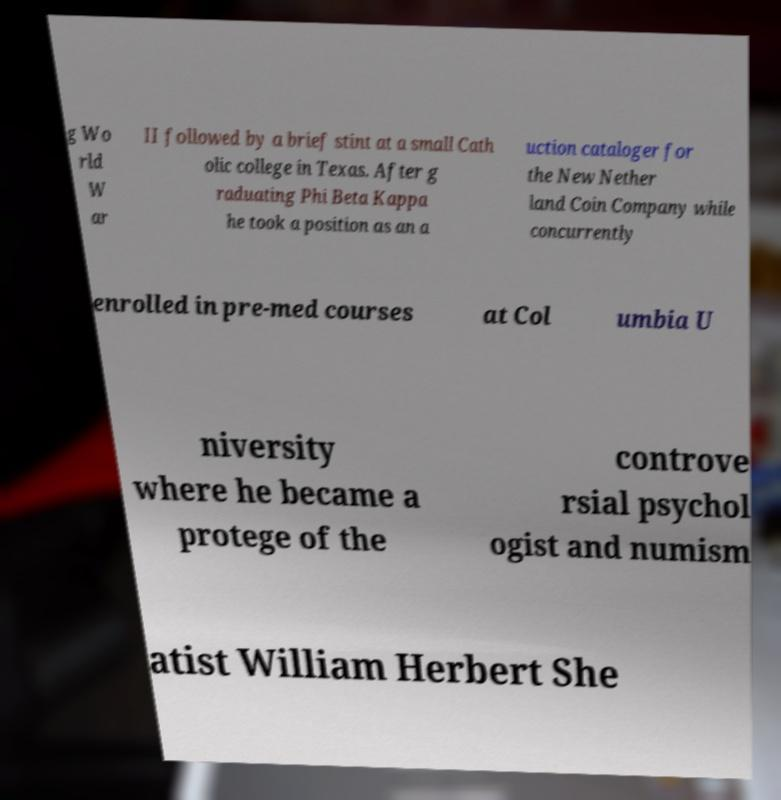Could you assist in decoding the text presented in this image and type it out clearly? g Wo rld W ar II followed by a brief stint at a small Cath olic college in Texas. After g raduating Phi Beta Kappa he took a position as an a uction cataloger for the New Nether land Coin Company while concurrently enrolled in pre-med courses at Col umbia U niversity where he became a protege of the controve rsial psychol ogist and numism atist William Herbert She 